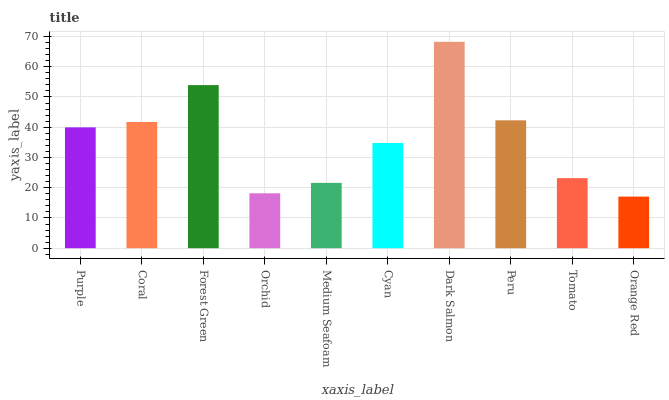Is Orange Red the minimum?
Answer yes or no. Yes. Is Dark Salmon the maximum?
Answer yes or no. Yes. Is Coral the minimum?
Answer yes or no. No. Is Coral the maximum?
Answer yes or no. No. Is Coral greater than Purple?
Answer yes or no. Yes. Is Purple less than Coral?
Answer yes or no. Yes. Is Purple greater than Coral?
Answer yes or no. No. Is Coral less than Purple?
Answer yes or no. No. Is Purple the high median?
Answer yes or no. Yes. Is Cyan the low median?
Answer yes or no. Yes. Is Coral the high median?
Answer yes or no. No. Is Forest Green the low median?
Answer yes or no. No. 